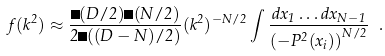Convert formula to latex. <formula><loc_0><loc_0><loc_500><loc_500>f ( k ^ { 2 } ) \approx \frac { \Gamma ( D / 2 ) \Gamma ( N / 2 ) } { 2 \Gamma ( ( D - N ) / 2 ) } ( k ^ { 2 } ) ^ { - N / 2 } \int \frac { d x _ { 1 } \dots d x _ { N - 1 } } { \left ( - P ^ { 2 } ( x _ { i } ) \right ) ^ { N / 2 } } \ .</formula> 